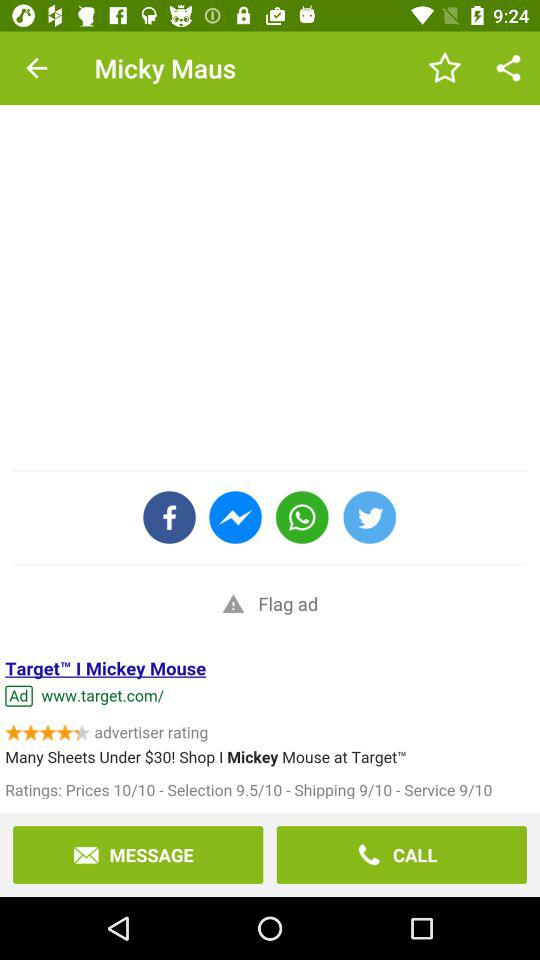What's the application name?
When the provided information is insufficient, respond with <no answer>. <no answer> 